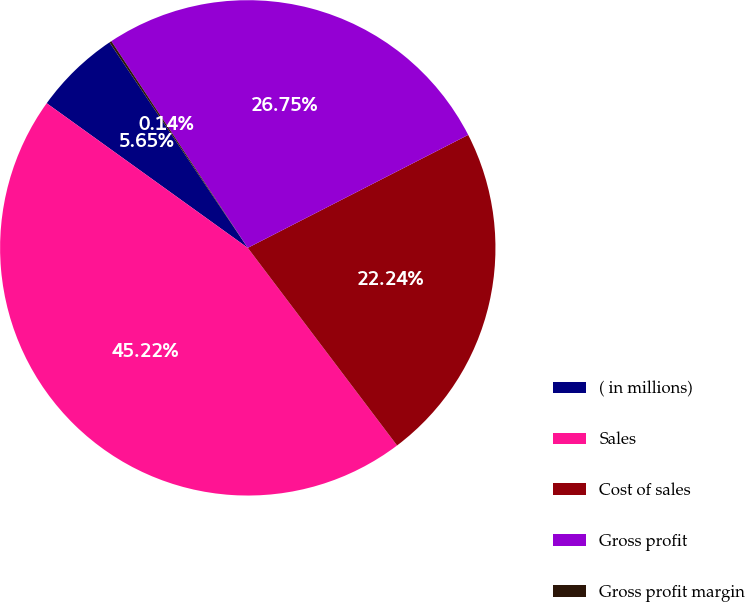Convert chart. <chart><loc_0><loc_0><loc_500><loc_500><pie_chart><fcel>( in millions)<fcel>Sales<fcel>Cost of sales<fcel>Gross profit<fcel>Gross profit margin<nl><fcel>5.65%<fcel>45.22%<fcel>22.24%<fcel>26.75%<fcel>0.14%<nl></chart> 